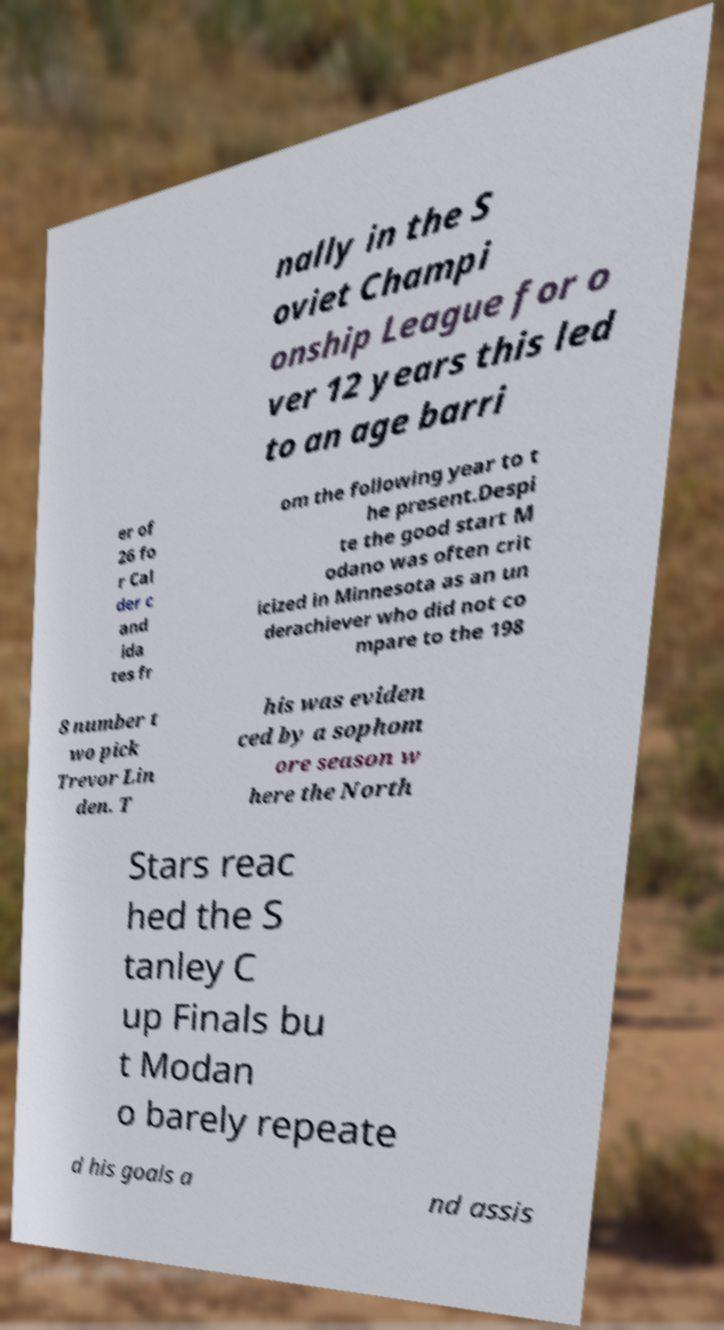What messages or text are displayed in this image? I need them in a readable, typed format. nally in the S oviet Champi onship League for o ver 12 years this led to an age barri er of 26 fo r Cal der c and ida tes fr om the following year to t he present.Despi te the good start M odano was often crit icized in Minnesota as an un derachiever who did not co mpare to the 198 8 number t wo pick Trevor Lin den. T his was eviden ced by a sophom ore season w here the North Stars reac hed the S tanley C up Finals bu t Modan o barely repeate d his goals a nd assis 